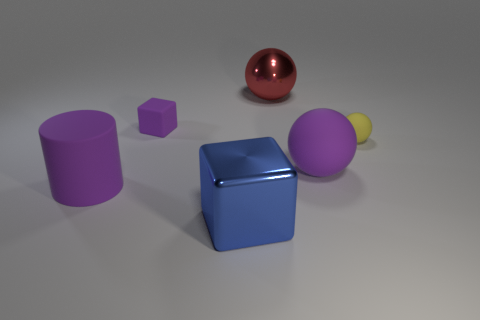Subtract all big purple rubber balls. How many balls are left? 2 Subtract 2 spheres. How many spheres are left? 1 Subtract all red spheres. How many spheres are left? 2 Add 2 cubes. How many objects exist? 8 Subtract all cylinders. How many objects are left? 5 Subtract all green spheres. Subtract all purple cylinders. How many spheres are left? 3 Subtract all purple cylinders. How many purple cubes are left? 1 Subtract all large green balls. Subtract all big purple rubber spheres. How many objects are left? 5 Add 3 large red objects. How many large red objects are left? 4 Add 3 purple rubber balls. How many purple rubber balls exist? 4 